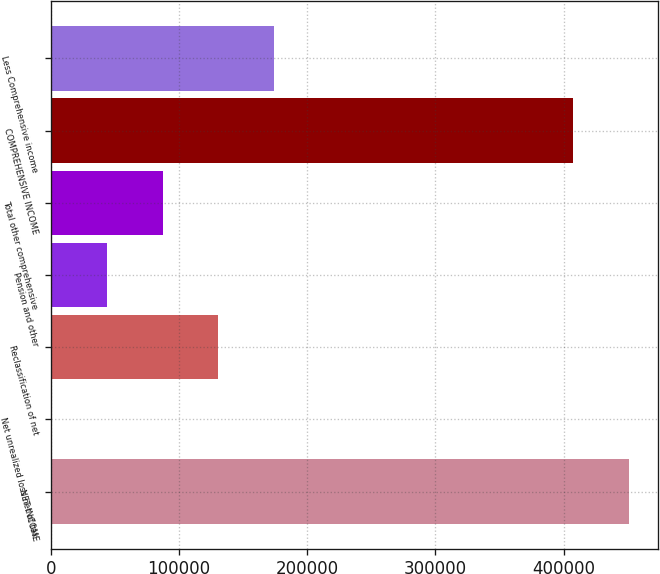<chart> <loc_0><loc_0><loc_500><loc_500><bar_chart><fcel>NET INCOME<fcel>Net unrealized loss net of tax<fcel>Reclassification of net<fcel>Pension and other<fcel>Total other comprehensive<fcel>COMPREHENSIVE INCOME<fcel>Less Comprehensive income<nl><fcel>450787<fcel>810<fcel>130649<fcel>44089.8<fcel>87369.6<fcel>407507<fcel>173929<nl></chart> 